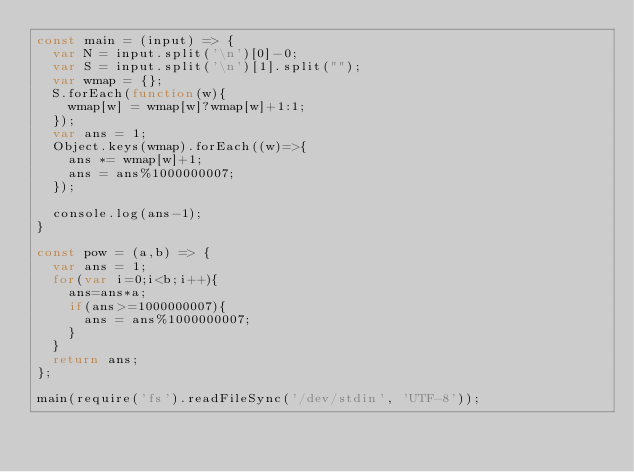<code> <loc_0><loc_0><loc_500><loc_500><_JavaScript_>const main = (input) => {
  var N = input.split('\n')[0]-0;
  var S = input.split('\n')[1].split("");
  var wmap = {};
  S.forEach(function(w){
    wmap[w] = wmap[w]?wmap[w]+1:1;
  });
  var ans = 1;
  Object.keys(wmap).forEach((w)=>{
    ans *= wmap[w]+1;
    ans = ans%1000000007;
  });

  console.log(ans-1);
}

const pow = (a,b) => {
  var ans = 1;
  for(var i=0;i<b;i++){
    ans=ans*a;
    if(ans>=1000000007){
      ans = ans%1000000007;
    }
  }
  return ans;
};

main(require('fs').readFileSync('/dev/stdin', 'UTF-8'));
</code> 